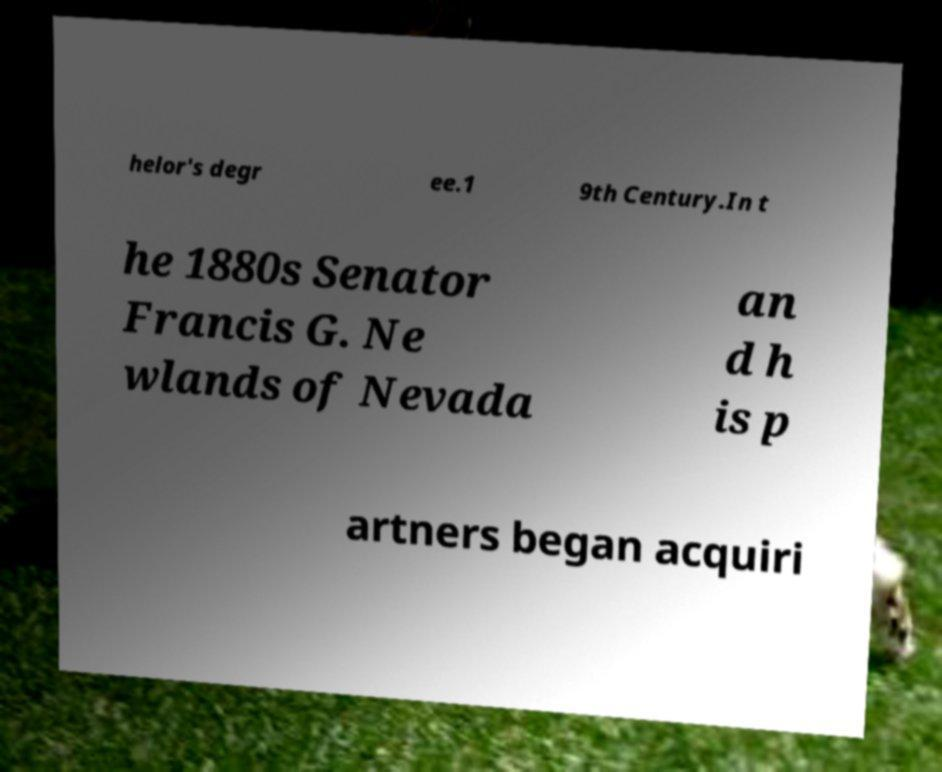Can you read and provide the text displayed in the image?This photo seems to have some interesting text. Can you extract and type it out for me? helor's degr ee.1 9th Century.In t he 1880s Senator Francis G. Ne wlands of Nevada an d h is p artners began acquiri 